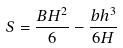Convert formula to latex. <formula><loc_0><loc_0><loc_500><loc_500>S = \frac { B H ^ { 2 } } { 6 } - \frac { b h ^ { 3 } } { 6 H }</formula> 